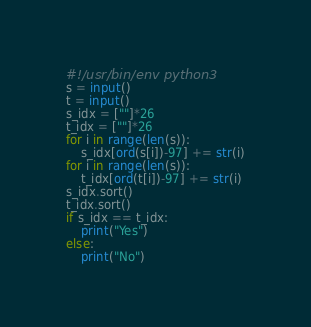<code> <loc_0><loc_0><loc_500><loc_500><_Python_>#!/usr/bin/env python3
s = input()
t = input()
s_idx = [""]*26
t_idx = [""]*26
for i in range(len(s)):
    s_idx[ord(s[i])-97] += str(i)
for i in range(len(s)):
    t_idx[ord(t[i])-97] += str(i)
s_idx.sort()
t_idx.sort()
if s_idx == t_idx:
    print("Yes")
else:
    print("No")
</code> 